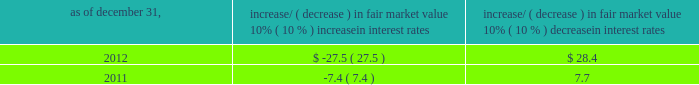Item 7a .
Quantitative and qualitative disclosures about market risk ( amounts in millions ) in the normal course of business , we are exposed to market risks related to interest rates , foreign currency rates and certain balance sheet items .
From time to time , we use derivative instruments , pursuant to established guidelines and policies , to manage some portion of these risks .
Derivative instruments utilized in our hedging activities are viewed as risk management tools and are not used for trading or speculative purposes .
Interest rates our exposure to market risk for changes in interest rates relates primarily to the fair market value and cash flows of our debt obligations .
The majority of our debt ( approximately 93% ( 93 % ) and 91% ( 91 % ) as of december 31 , 2012 and 2011 , respectively ) bears interest at fixed rates .
We do have debt with variable interest rates , but a 10% ( 10 % ) increase or decrease in interest rates would not be material to our interest expense or cash flows .
The fair market value of our debt is sensitive to changes in interest rates , and the impact of a 10% ( 10 % ) change in interest rates is summarized below .
Increase/ ( decrease ) in fair market value as of december 31 , 10% ( 10 % ) increase in interest rates 10% ( 10 % ) decrease in interest rates .
We have used interest rate swaps for risk management purposes to manage our exposure to changes in interest rates .
During 2012 , we entered into and exited forward-starting interest rate swap agreements to effectively lock in the benchmark rate related to our 3.75% ( 3.75 % ) senior notes due 2023 , which we issued in november 2012 .
We do not have any interest rate swaps outstanding as of december 31 , 2012 .
We had $ 2590.8 of cash , cash equivalents and marketable securities as of december 31 , 2012 that we generally invest in conservative , short-term investment-grade securities .
The interest income generated from these investments is subject to both domestic and foreign interest rate movements .
During 2012 and 2011 , we had interest income of $ 29.5 and $ 37.8 , respectively .
Based on our 2012 results , a 100 basis point increase or decrease in interest rates would affect our interest income by approximately $ 26.0 , assuming that all cash , cash equivalents and marketable securities are impacted in the same manner and balances remain constant from year-end 2012 levels .
Foreign currency rates we are subject to translation and transaction risks related to changes in foreign currency exchange rates .
Since we report revenues and expenses in u.s .
Dollars , changes in exchange rates may either positively or negatively affect our consolidated revenues and expenses ( as expressed in u.s .
Dollars ) from foreign operations .
The primary foreign currencies that impacted our results during 2012 were the brazilian real , euro , indian rupee and the south african rand .
Based on 2012 exchange rates and operating results , if the u.s .
Dollar were to strengthen or weaken by 10% ( 10 % ) , we currently estimate operating income would decrease or increase between 3% ( 3 % ) and 5% ( 5 % ) , assuming that all currencies are impacted in the same manner and our international revenue and expenses remain constant at 2012 levels .
The functional currency of our foreign operations is generally their respective local currency .
Assets and liabilities are translated at the exchange rates in effect at the balance sheet date , and revenues and expenses are translated at the average exchange rates during the period presented .
The resulting translation adjustments are recorded as a component of accumulated other comprehensive loss , net of tax , in the stockholders 2019 equity section of our consolidated balance sheets .
Our foreign subsidiaries generally collect revenues and pay expenses in their functional currency , mitigating transaction risk .
However , certain subsidiaries may enter into transactions in currencies other than their functional currency .
Assets and liabilities denominated in currencies other than the functional currency are susceptible to movements in foreign currency until final settlement .
Currency transaction gains or losses primarily arising from transactions in currencies other than the functional currency are included in office and general expenses .
We have not entered into a material amount of foreign currency forward exchange contracts or other derivative financial instruments to hedge the effects of potential adverse fluctuations in foreign currency exchange rates. .
What was the total amount of interest income combined in 2011 and 2012 , in millions? 
Computations: (29.5 + 37.8)
Answer: 67.3. 